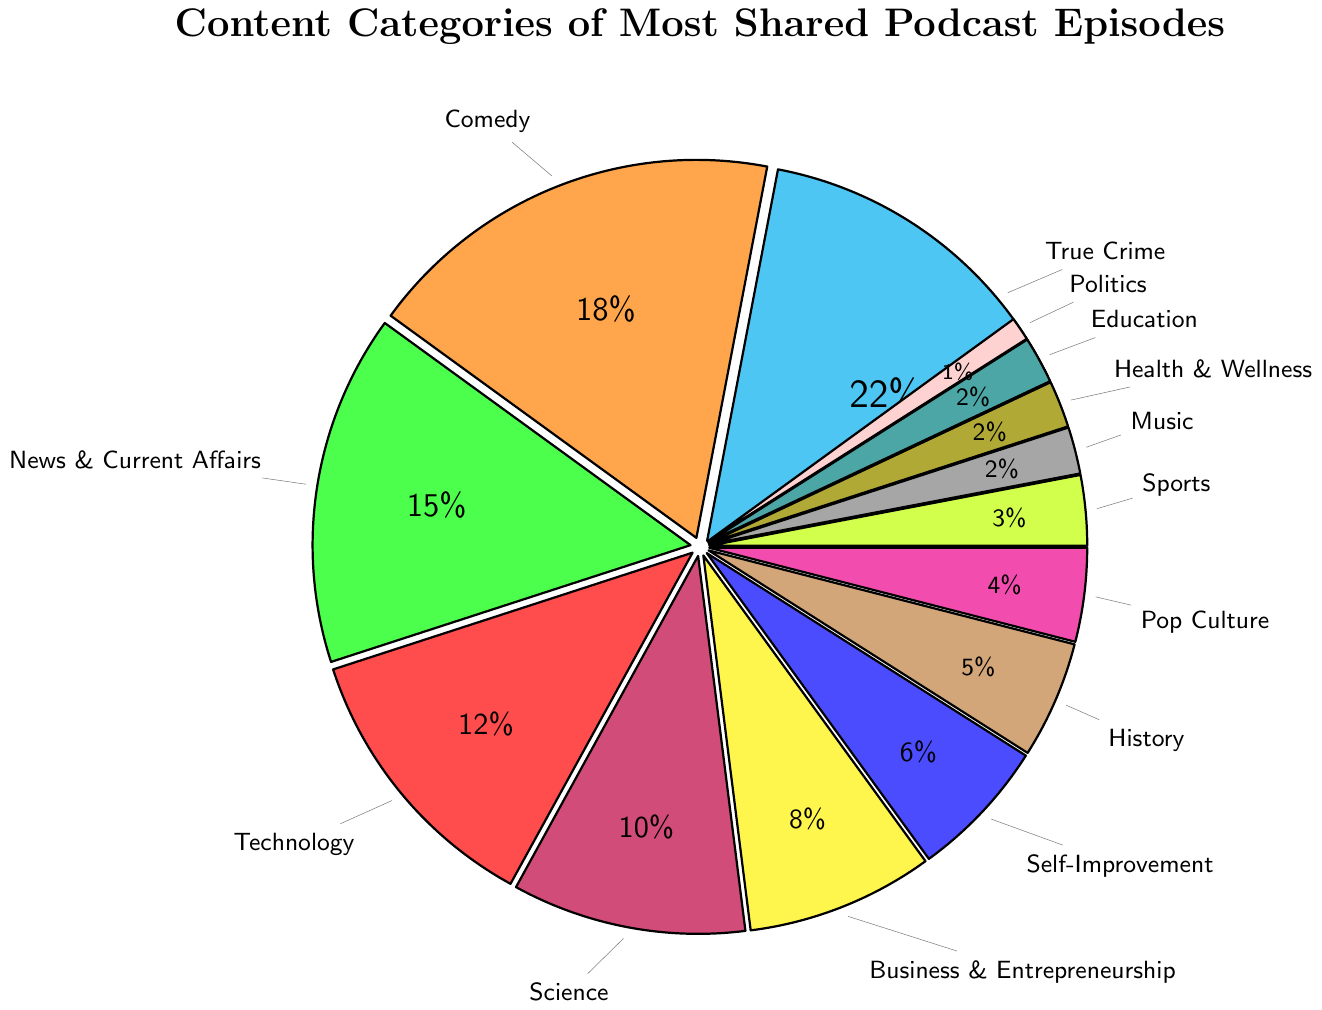What is the most shared content category of podcast episodes on social media? The largest slice of the pie chart represents the most shared content category. The "True Crime" category takes up the largest portion, indicated by a 22% share.
Answer: True Crime Which content category has a higher share, Comedy or Technology? To determine this, compare the percentages for Comedy and Technology. Comedy has 18%, while Technology has 12%. Therefore, Comedy has a higher share.
Answer: Comedy How many categories have a share of 2%? Identify the slices with a 2% share. The categories with 2% are Music, Health & Wellness, and Education. That's three categories.
Answer: 3 What is the combined percentage of News & Current Affairs and Technology? Add the percentages for News & Current Affairs (15%) and Technology (12%). The combined share is 15% + 12% = 27%.
Answer: 27% Which two categories have the smallest shares? The smallest slices in the pie chart are Politics and Music, Health & Wellness, and Education, each with a 2% share. Since Politics has 1%, it is the smallest, followed by the three 2% slices.
Answer: Politics and Music, Health & Wellness, and Education What is the total percentage of categories related to entertainment (Comedy and Pop Culture)? Add the percentages for Comedy (18%) and Pop Culture (4%). The total share for entertainment-related categories is 18% + 4% = 22%.
Answer: 22% Is the percentage share of Self-Improvement greater than the combined share of Music and Sports? Compare the percentage of Self-Improvement (6%) with the combined percentage of Music (2%) and Sports (3%). Self-Improvement is 6%, while Music and Sports together make up 2% + 3% = 5%. 6% is greater than 5%, so yes.
Answer: Yes What categories have a share equal to or lower than 5%? Identify slices with a percentage equal to or lower than 5%. These are History (5%), Pop Culture (4%), Sports (3%), Music (2%), Health & Wellness (2%), Education (2%), and Politics (1%).
Answer: History, Pop Culture, Sports, Music, Health & Wellness, Education, and Politics How much larger is the share for Science compared to Self-Improvement? Subtract the percentage share of Self-Improvement (6%) from Science (10%). The difference is 10% - 6% = 4%.
Answer: 4% Which content category is represented by the blue slice of the pie chart? Follow the color sequence indicated in the chart creation guidelines. Based on the sequence, the blue slice represents Business & Entrepreneurship (8%).
Answer: Business & Entrepreneurship 